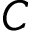<formula> <loc_0><loc_0><loc_500><loc_500>C</formula> 